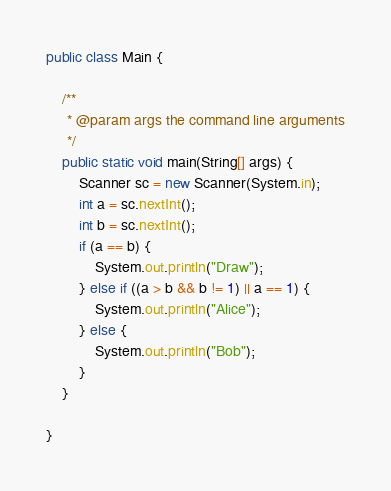Convert code to text. <code><loc_0><loc_0><loc_500><loc_500><_Java_>public class Main {

    /**
     * @param args the command line arguments
     */
    public static void main(String[] args) {
        Scanner sc = new Scanner(System.in);
        int a = sc.nextInt();
        int b = sc.nextInt();
        if (a == b) {
            System.out.println("Draw");
        } else if ((a > b && b != 1) || a == 1) {
            System.out.println("Alice");
        } else {
            System.out.println("Bob");
        }
    }

}</code> 